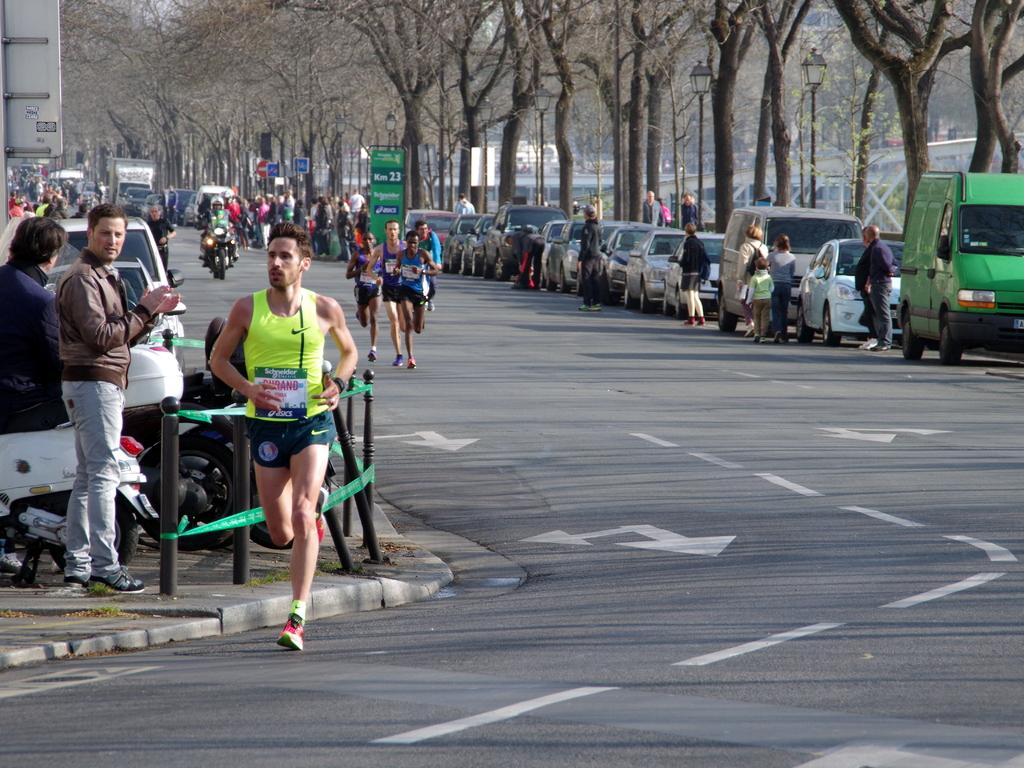How many people are in the image? There are people in the image, but the exact number is not specified. What are some of the people doing in the image? Some of the people are running on the road. What can be seen in the background of the image? There are vehicles, trees, and a fence in the background of the image. What type of lighting is present in the image? Street lights are present in the image. What else is visible in the image besides the people and the background? Boards are visible in the image. Reasoning: Let'g: Let's think step by step in order to produce the conversation. We start by acknowledging the presence of people in the image, but we avoid specifying an exact number since it is not mentioned in the facts. Next, we describe the actions of some of the people, who are running on the road. Then, we focus on the background of the image, mentioning the vehicles, trees, and fence. We also include the street lights as a detail about the lighting in the image. Finally, we mention the presence of boards as an additional element visible in the image. Absurd Question/Answer: What type of soap is being used by the bird in the image? There is no bird or soap present in the image. How does the train affect the people running on the road in the image? There is no train present in the image, so it cannot affect the people running on the road. 